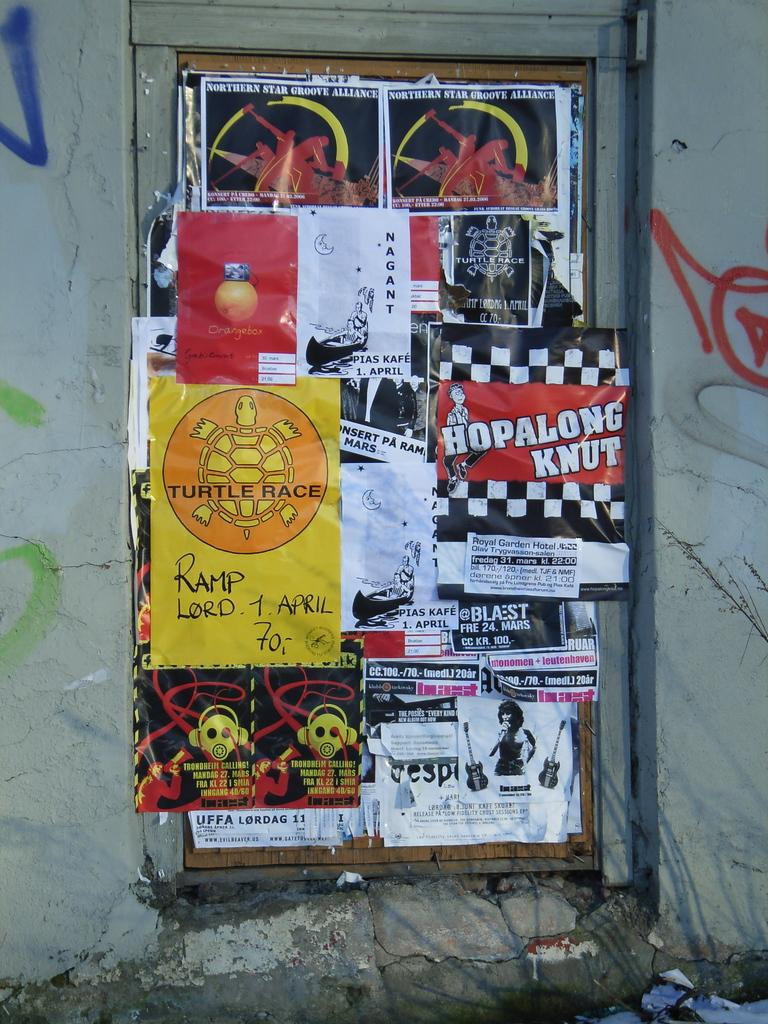<image>
Render a clear and concise summary of the photo. A bulletin board crowded with flyers and posters, one of which is for Hopalong Knut. 